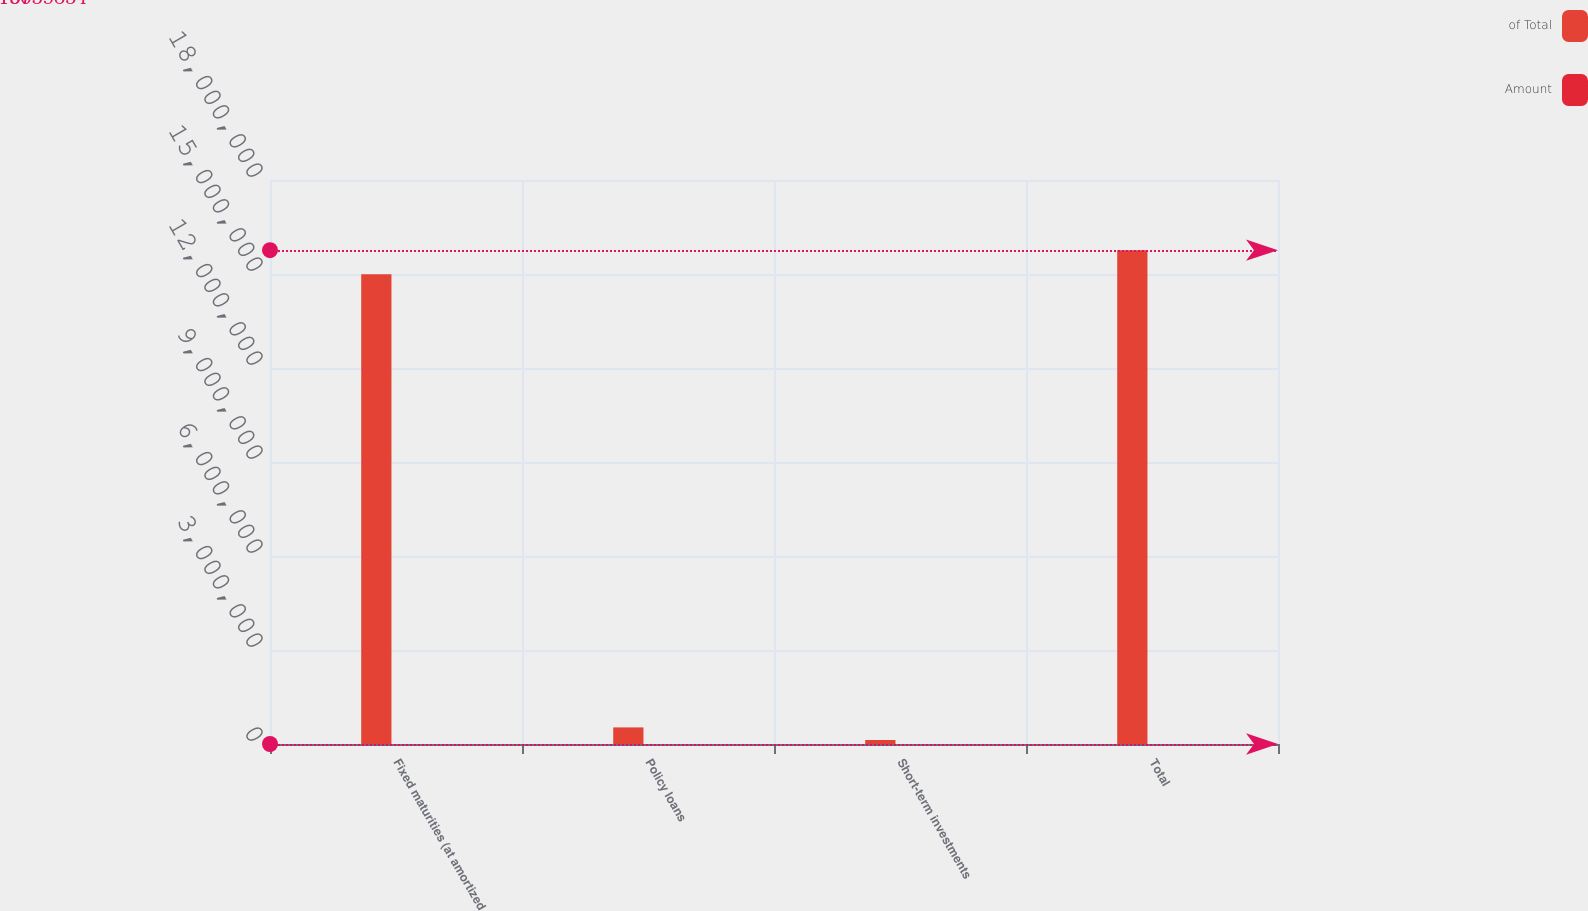Convert chart. <chart><loc_0><loc_0><loc_500><loc_500><stacked_bar_chart><ecel><fcel>Fixed maturities (at amortized<fcel>Policy loans<fcel>Short-term investments<fcel>Total<nl><fcel>of Total<fcel>1.49951e+07<fcel>529529<fcel>127071<fcel>1.57597e+07<nl><fcel>Amount<fcel>95<fcel>3<fcel>1<fcel>100<nl></chart> 